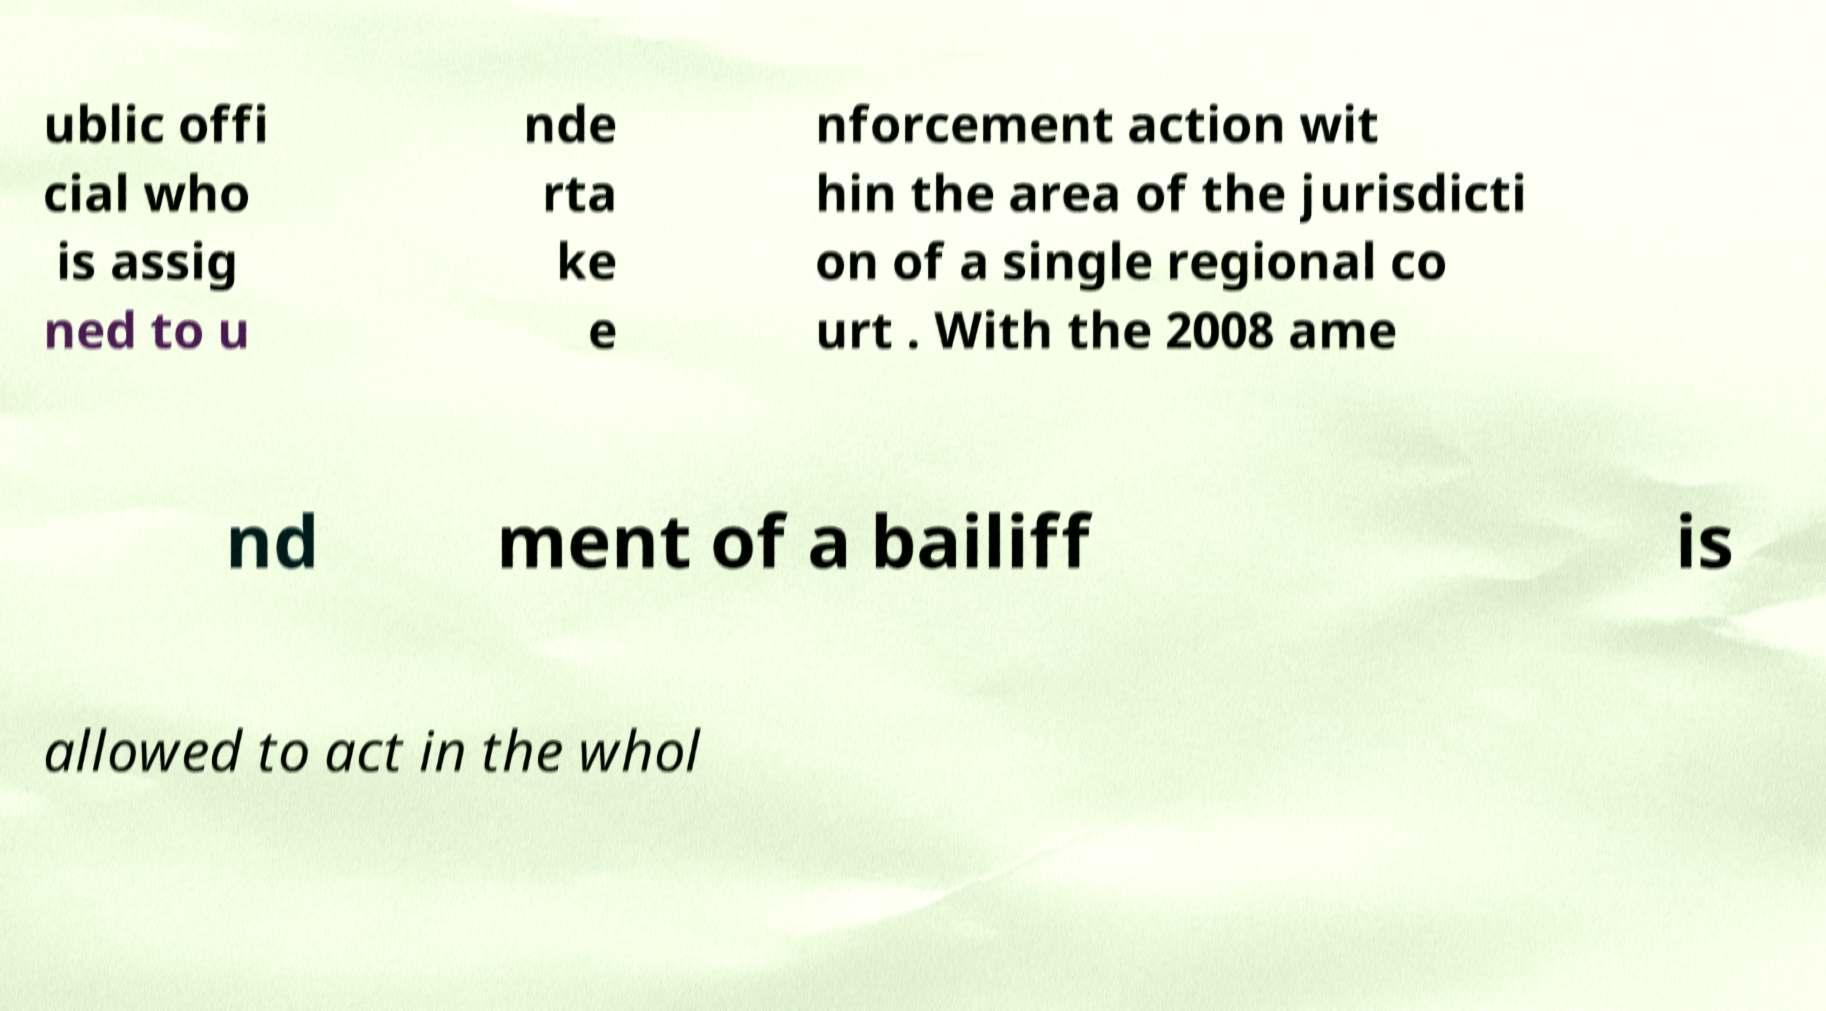For documentation purposes, I need the text within this image transcribed. Could you provide that? ublic offi cial who is assig ned to u nde rta ke e nforcement action wit hin the area of the jurisdicti on of a single regional co urt . With the 2008 ame nd ment of a bailiff is allowed to act in the whol 